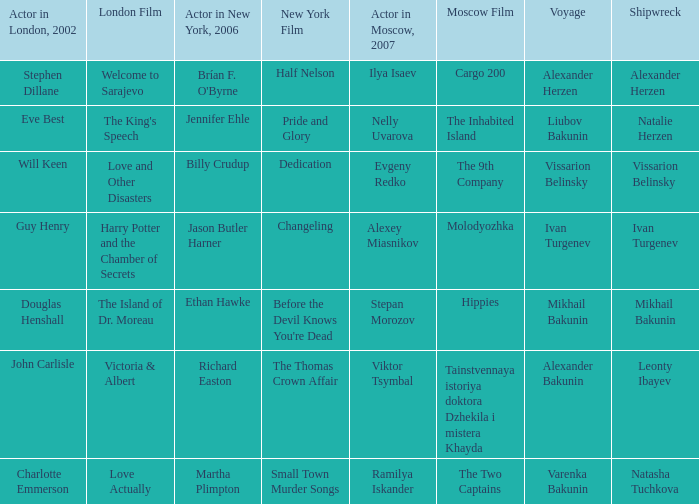Which moscow-based actor was involved in the representation of leonty ibayev's shipwreck in 2007? Viktor Tsymbal. 